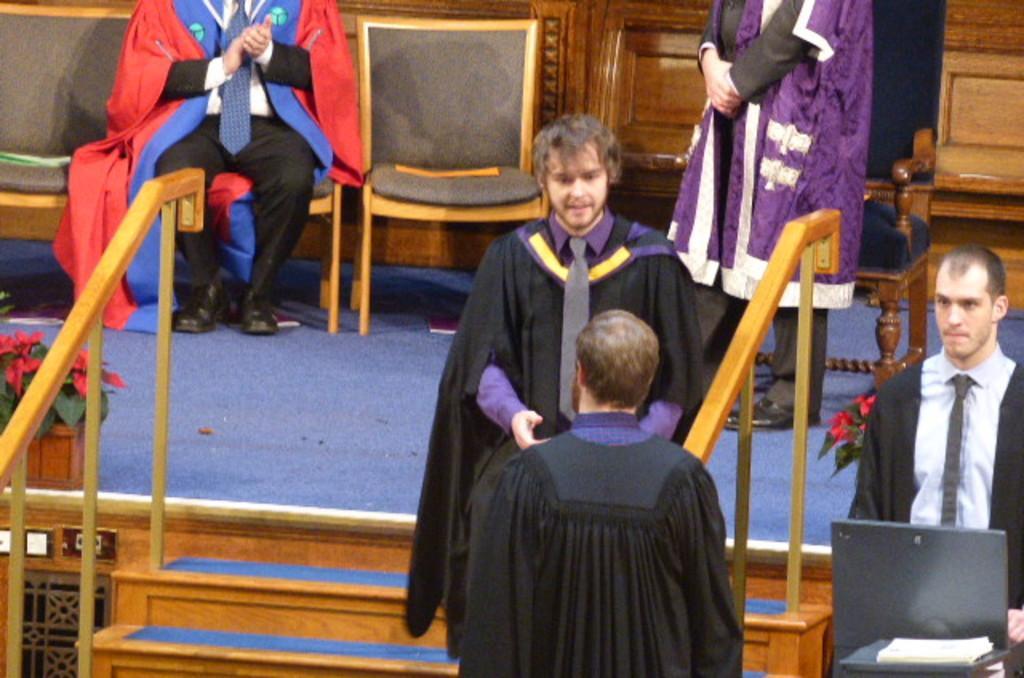Describe this image in one or two sentences. This picture describes about group of people, few are standing and a man is seated on the chair, in front of him we can see few flowers and plants. 